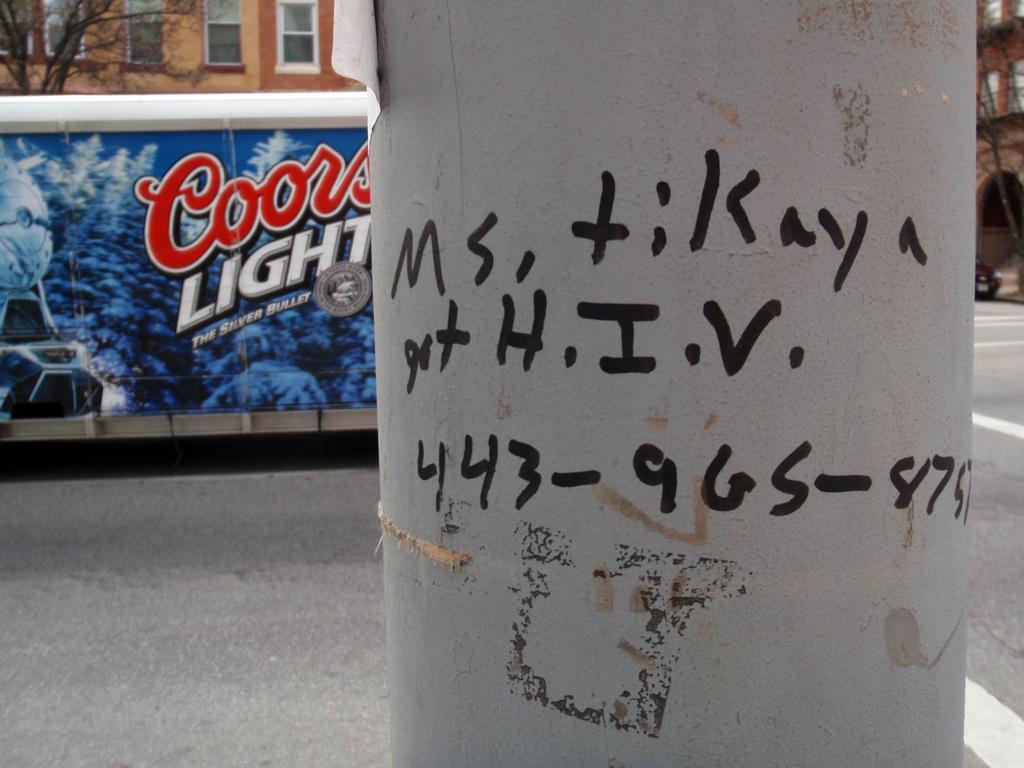How would you summarize this image in a sentence or two? In this image there are some letters written on the pole, and in the background there are buildings, poster, trees, vehicle, road. 